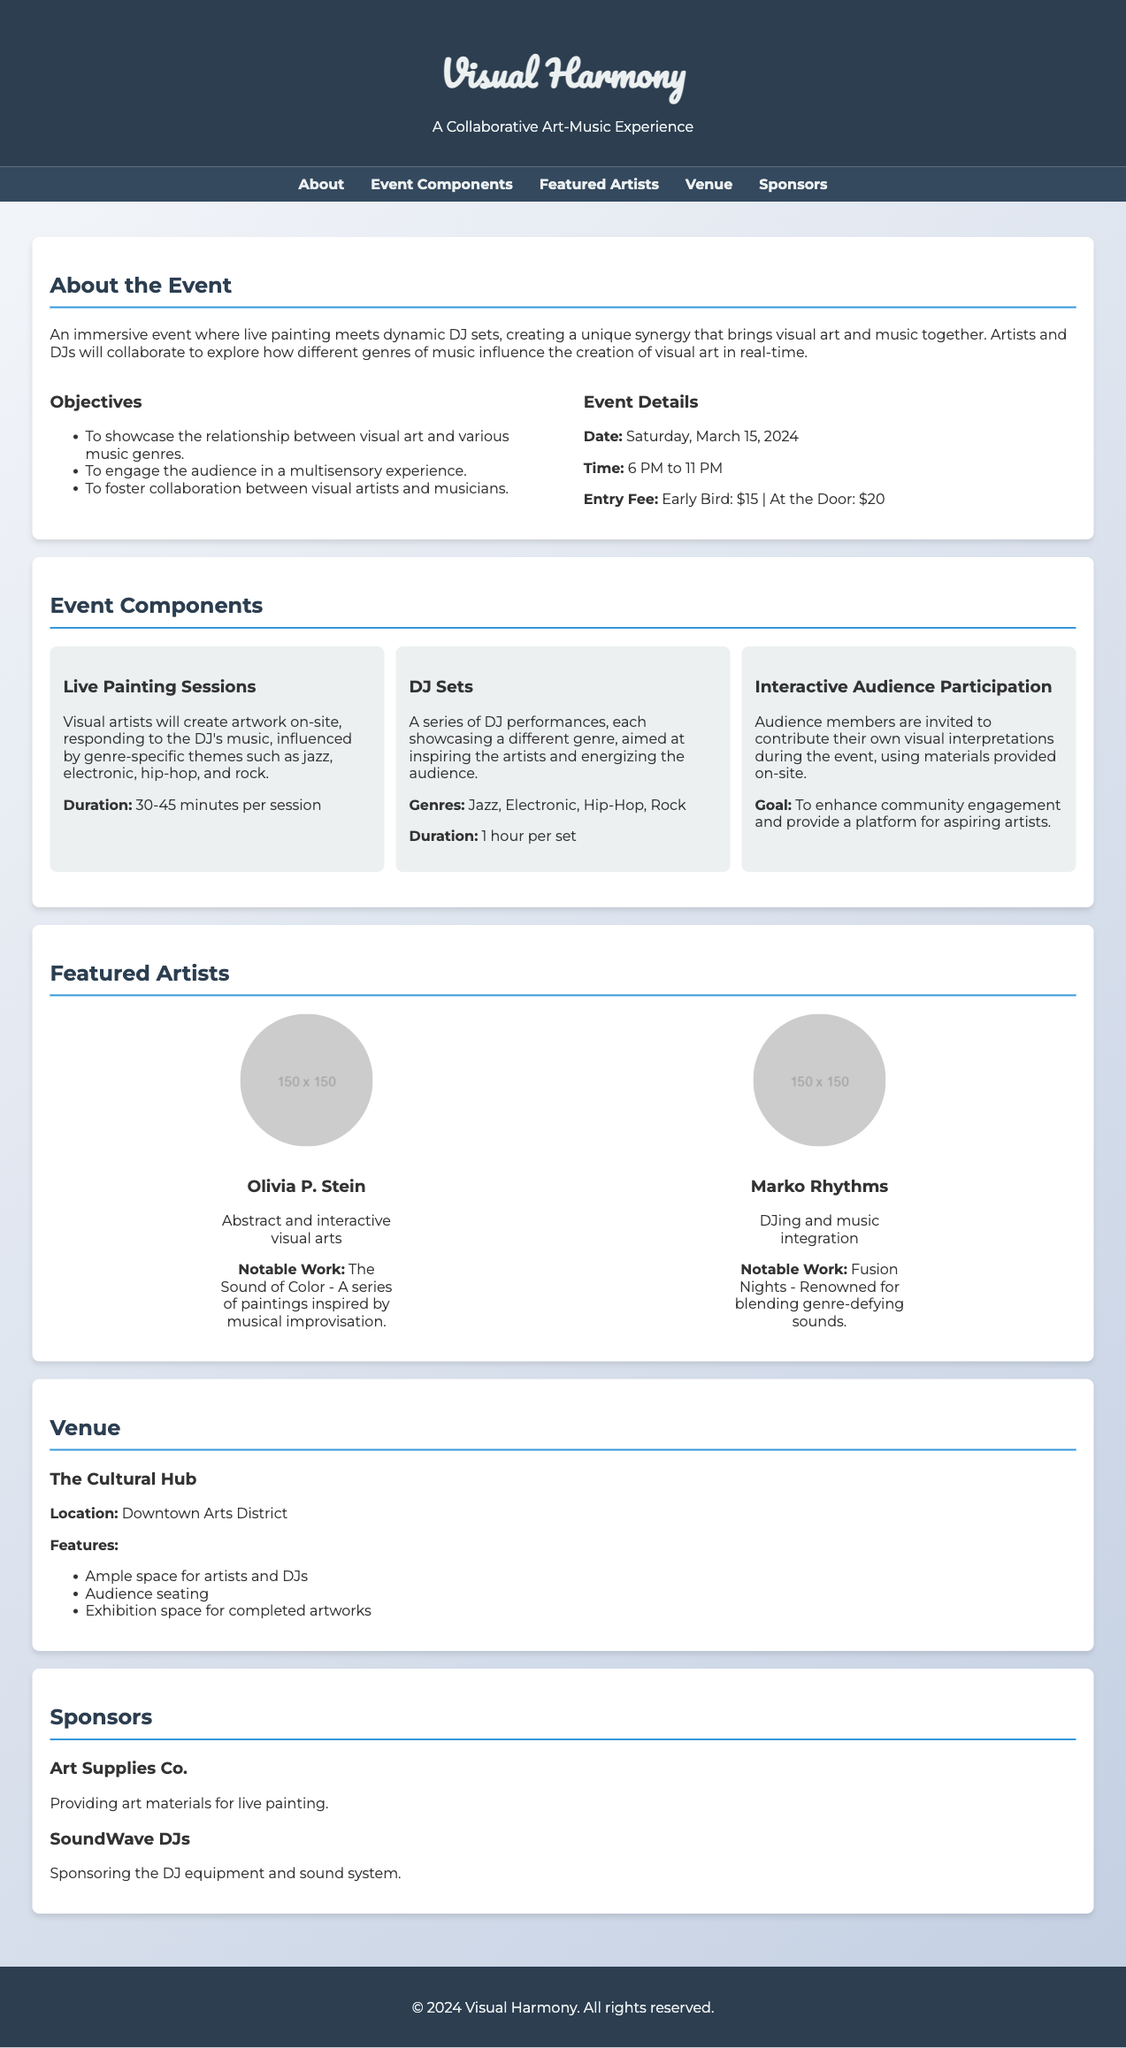What is the date of the event? The event is scheduled for Saturday, March 15, 2024, as stated in the event details section.
Answer: Saturday, March 15, 2024 What is the entry fee for early bird tickets? The entry fee for early bird tickets is listed as $15 in the event details.
Answer: $15 Who is one of the featured artists? The document mentions Olivia P. Stein as one of the featured artists in the artists section.
Answer: Olivia P. Stein What are the genres showcased by the DJs? The genres listed for the DJ sets are jazz, electronic, hip-hop, and rock, found in the event components section.
Answer: Jazz, Electronic, Hip-Hop, Rock What is the main objective of the event? The main objective mentioned is to showcase the relationship between visual art and various music genres, which is listed among the objectives.
Answer: Showcase the relationship between visual art and various music genres How long is each DJ set? Each DJ set is mentioned to last for 1 hour, as stated in the components section.
Answer: 1 hour What is the goal of the interactive audience participation? The goal of the interactive audience participation is stated as enhancing community engagement and providing a platform for aspiring artists.
Answer: Enhance community engagement and provide a platform for aspiring artists Where is the venue located? The venue is located in the Downtown Arts District, as specified in the venue section.
Answer: Downtown Arts District 